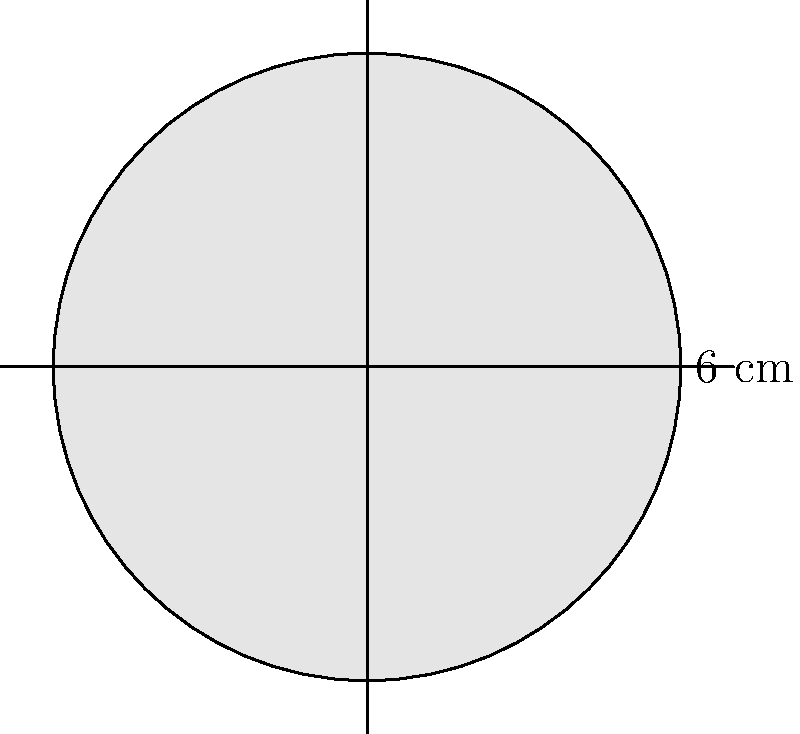In a Kandinsky-inspired composition, there's a prominent circular motif. If the diameter of this circle is 6 cm, what is the area of the circular motif? Round your answer to two decimal places. To find the area of the circular motif, we'll follow these steps:

1) First, recall the formula for the area of a circle:
   $A = \pi r^2$
   where $A$ is the area and $r$ is the radius.

2) We're given the diameter, which is 6 cm. The radius is half of the diameter:
   $r = \frac{6}{2} = 3$ cm

3) Now, let's substitute this into our area formula:
   $A = \pi (3)^2$

4) Simplify:
   $A = 9\pi$ cm²

5) Using $\pi \approx 3.14159$, we get:
   $A \approx 9 \times 3.14159 = 28.27431$ cm²

6) Rounding to two decimal places:
   $A \approx 28.27$ cm²

This mathematical approach to analyzing the composition reveals how Kandinsky, known for his interest in geometry, might have precisely planned his abstract forms.
Answer: $28.27$ cm² 